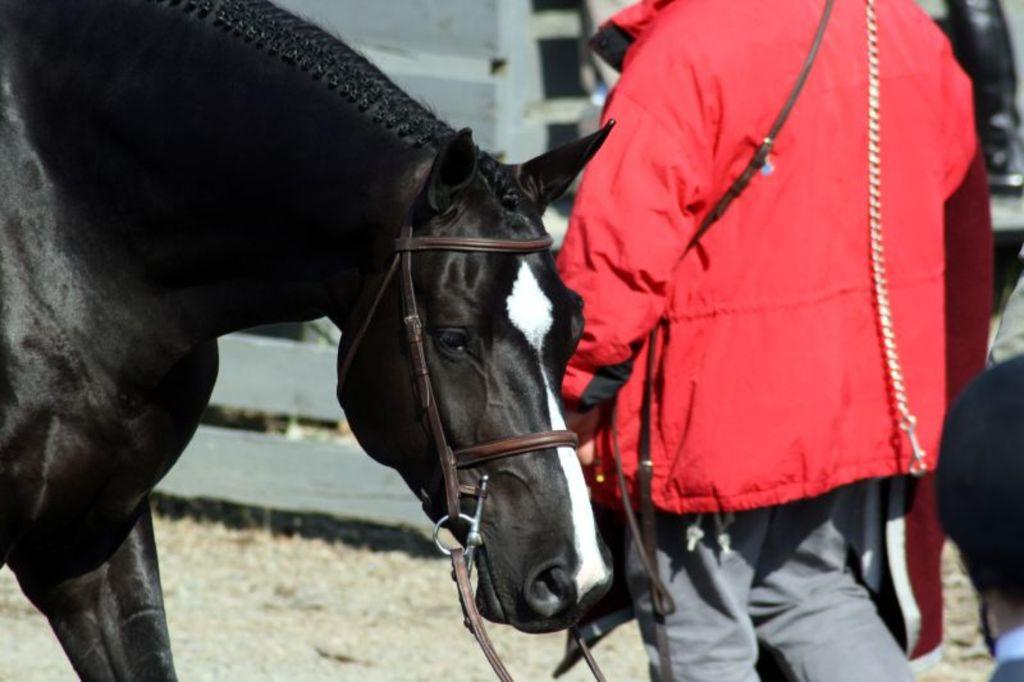What type of animal is in the picture? There is a black horse in the picture. Who else is in the picture besides the horse? There is a man in the picture. What is the man wearing? The man is wearing a red jacket. Where is the man positioned in relation to the horse? The man is standing behind the horse. How much butter is being used to grip the horse's reins in the image? There is no butter present in the image, and the horse's reins are not visible. 